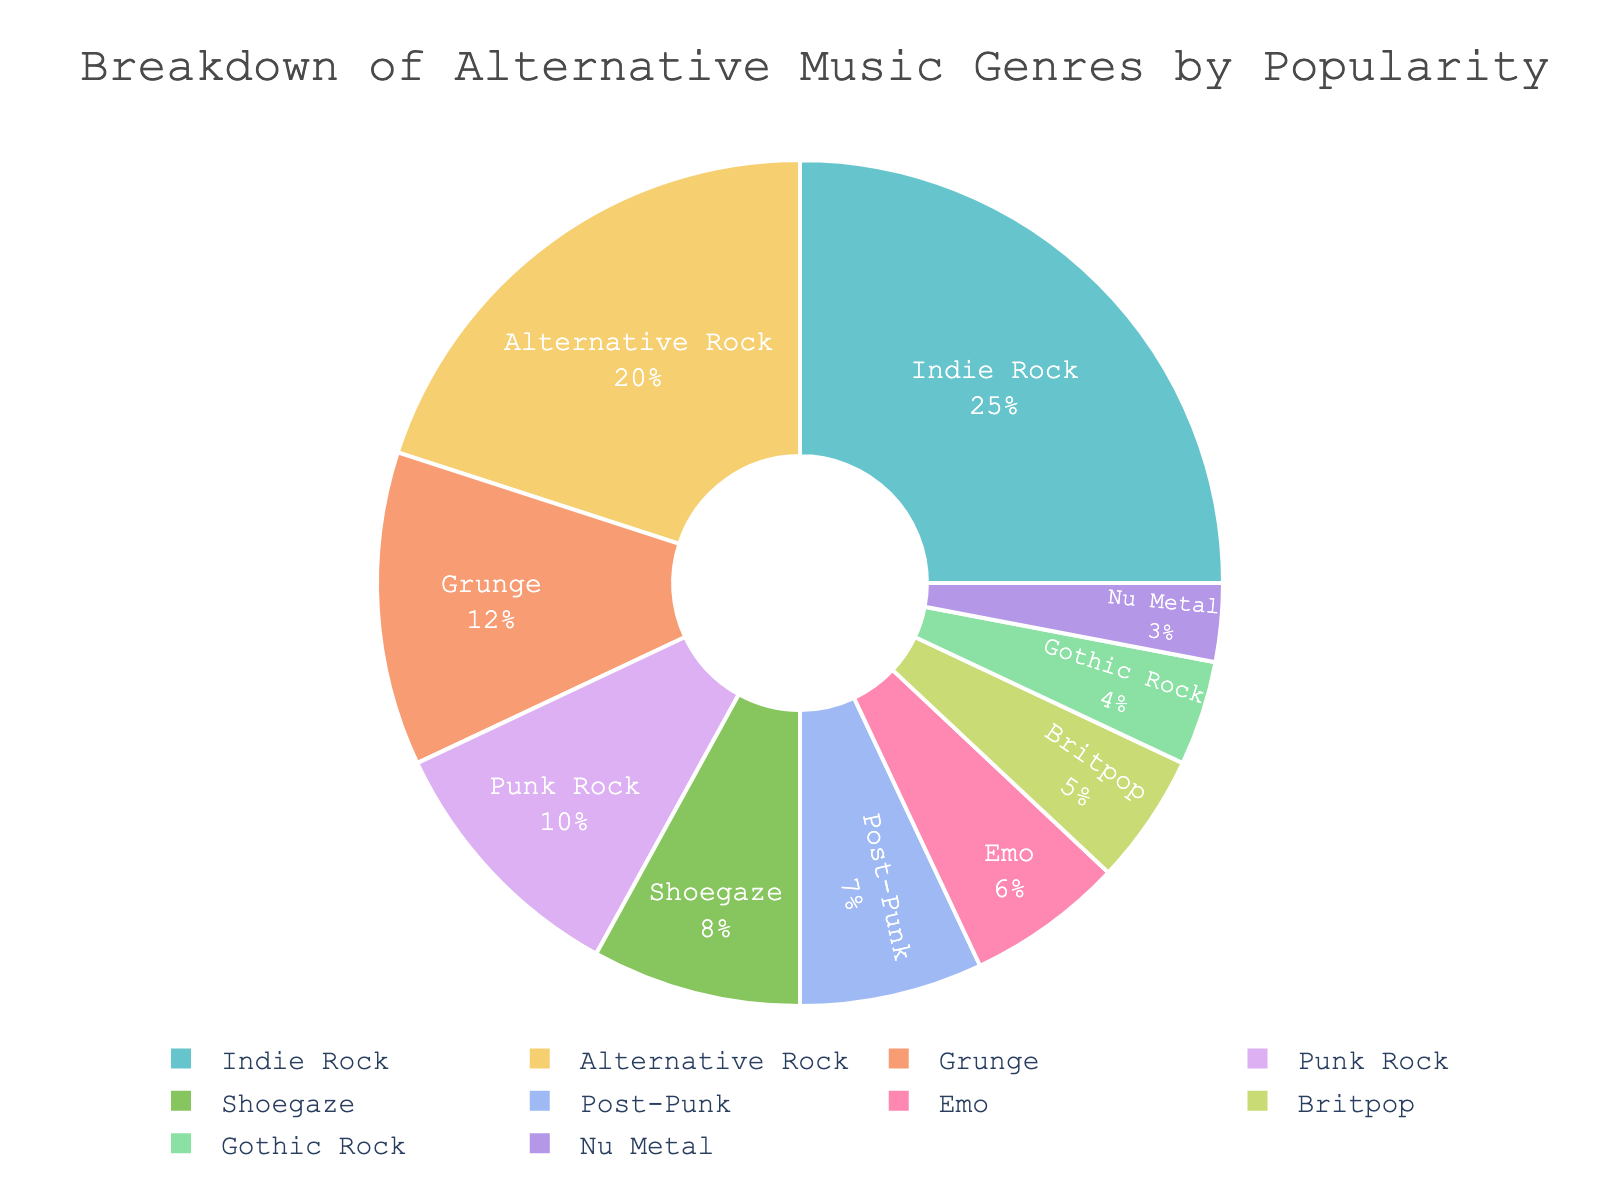Which genre is the most popular? The pie chart shows various genres by popularity with labels. The genre with the largest slice and highest percentage is the most popular.
Answer: Indie Rock Which genre has the smallest share? The pie chart's smallest slice and lowest percentage represent the least popular genre.
Answer: Nu Metal How much more popular is Indie Rock compared to Nu Metal? Refer to the percentages of both genres. Indie Rock is 25%, and Nu Metal is 3%. Subtract 3% from 25%. 25% - 3% = 22%
Answer: 22% What percentage of the chart is composed of Grunge and Shoegaze combined? Identify the slices for Grunge and Shoegaze, showing 12% and 8% respectively. Add these percentages. 12% + 8% = 20%
Answer: 20% Are there any genres that have equal popularity? Check if any slices show the same percentage. All percentages are unique in this chart.
Answer: No What is the combined popularity of all genres less popular than Shoegaze? Identify genres less popular than Shoegaze: Post-Punk (7%), Emo (6%), Britpop (5%), Gothic Rock (4%), Nu Metal (3%). Add these percentages. 7% + 6% + 5% + 4% + 3% = 25%
Answer: 25% How does the popularity of Alternative Rock compare to Punk Rock? Look at the percentages: Alternative Rock has 20%, and Punk Rock has 10%. Alternative Rock is twice as popular as Punk Rock.
Answer: Twice as popular Which genres together make up at least 50% of the total? Identify the largest slices adding up to 50% or more. Indie Rock (25%), Alternative Rock (20%), and Grunge (12%). Indie Rock + Alternative Rock = 45%; 45% + 12% = 57%.
Answer: Indie Rock, Alternative Rock, Grunge Which genre has more popularity: Gothic Rock or Britpop? Compare the percentages of Gothic Rock (4%) and Britpop (5%). Britpop is slightly more popular.
Answer: Britpop What is the total percentage of all rock-related genres in the chart (excluding subgenres like Emo or Nu Metal)? Combine the percentages: Indie Rock (25%), Alternative Rock (20%), Grunge (12%), Punk Rock (10%), Post-Punk (7%), Britpop (5%), Gothic Rock (4%). Add these percentages: 25% + 20% + 12% + 10% + 7% + 5% + 4% = 83%
Answer: 83% 